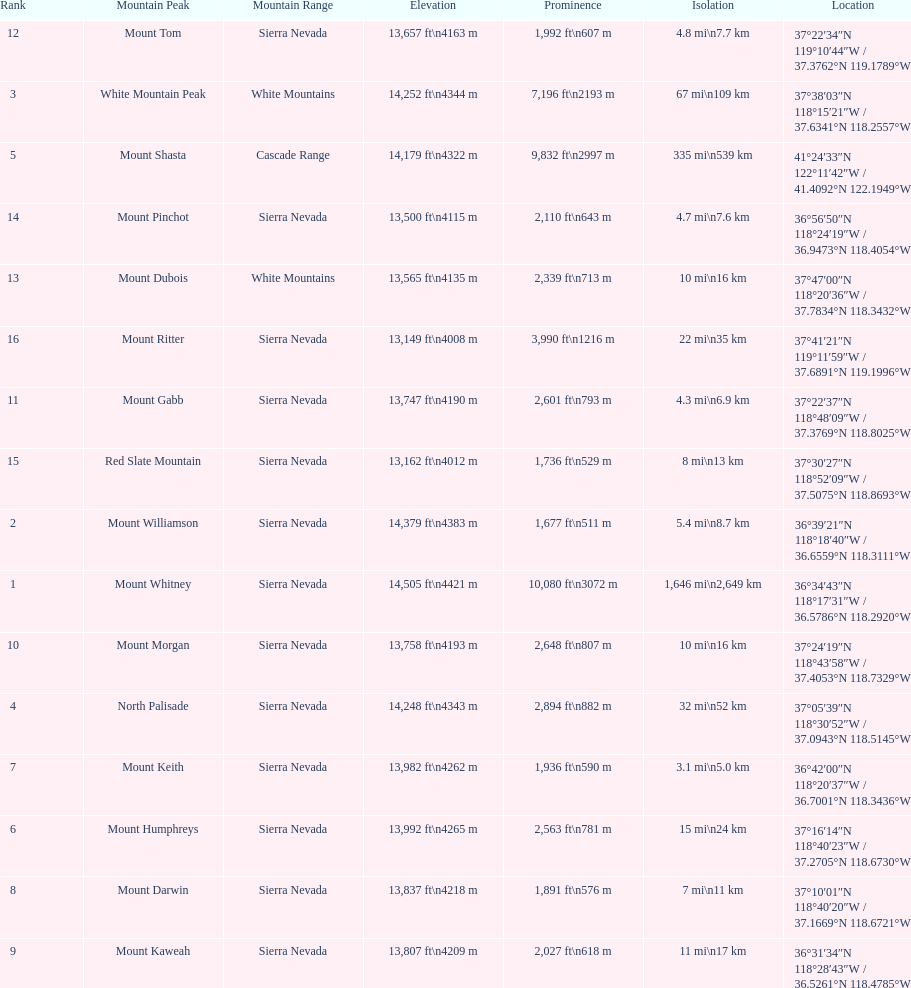Is the peak of mount keith above or below the peak of north palisade? Below. 